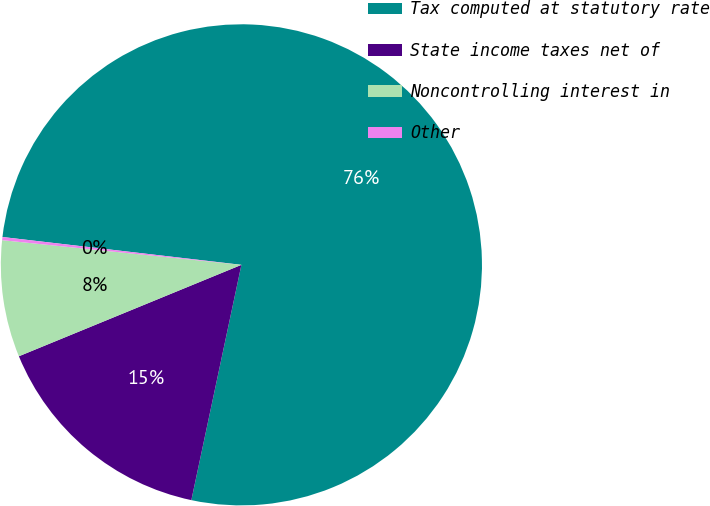Convert chart to OTSL. <chart><loc_0><loc_0><loc_500><loc_500><pie_chart><fcel>Tax computed at statutory rate<fcel>State income taxes net of<fcel>Noncontrolling interest in<fcel>Other<nl><fcel>76.49%<fcel>15.46%<fcel>7.84%<fcel>0.21%<nl></chart> 